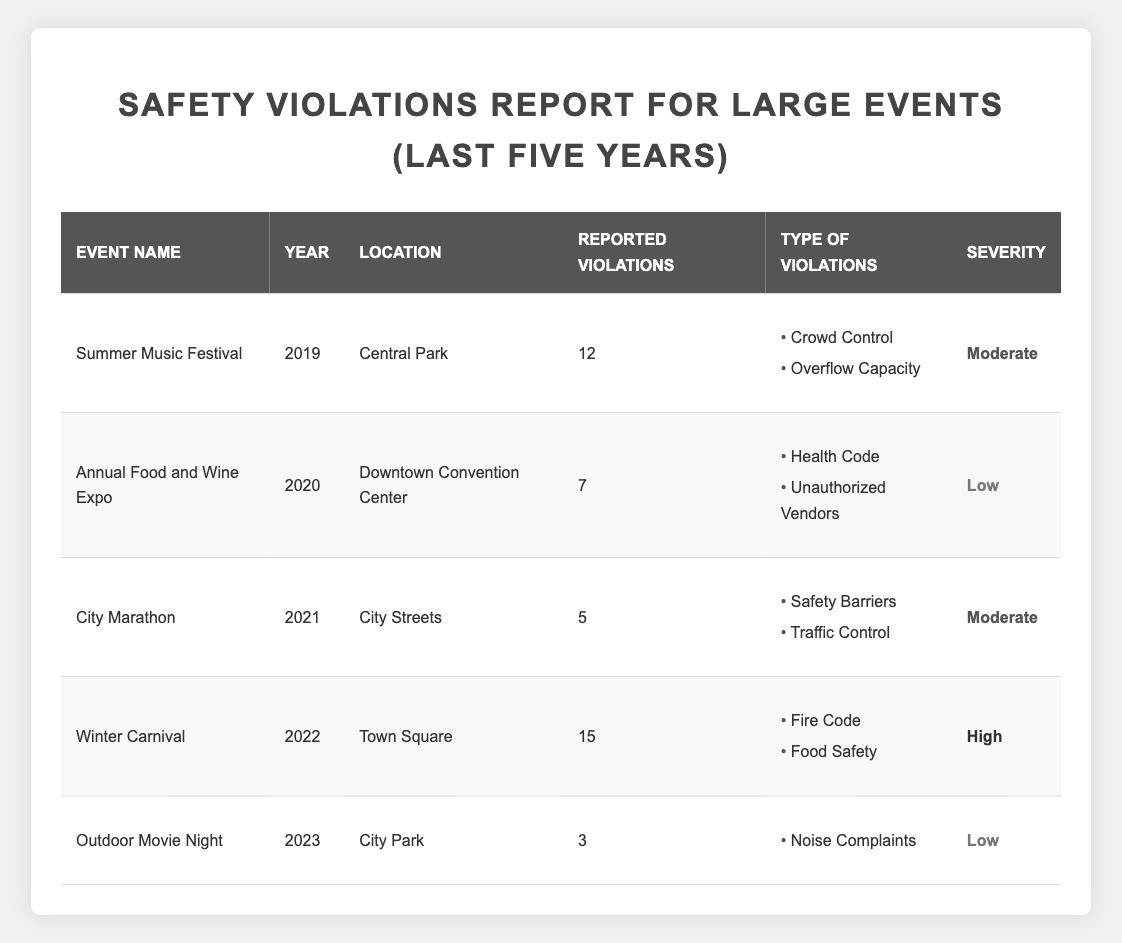What event reported the highest number of violations? Looking at the "Reported Violations" column, "Winter Carnival" has the highest value of 15 violations.
Answer: Winter Carnival How many events reported moderate severity violations? By reviewing the "Severity" column, the events "Summer Music Festival," "City Marathon," and "Winter Carnival" are classified as moderate, totaling 3 events.
Answer: 3 What is the total number of reported violations across all events listed? Adding the reported violations: 12 (Summer Music Festival) + 7 (Annual Food and Wine Expo) + 5 (City Marathon) + 15 (Winter Carnival) + 3 (Outdoor Movie Night) gives a total of 42 reported violations.
Answer: 42 Did the "Annual Food and Wine Expo" report any high severity violations? The "Severity" listed for "Annual Food and Wine Expo" is labeled as low, indicating no high severity violations were reported.
Answer: No In which year did the event with the lowest reported violations occur? The event with the lowest reported violations is "Outdoor Movie Night," which occurred in 2023, as it reported only 3 violations.
Answer: 2023 What is the average number of violations reported per event? To find the average, sum all reported violations (42) and divide by the number of events (5), resulting in an average of 42/5 = 8.4 violations per event.
Answer: 8.4 How many types of violations were reported for the "Winter Carnival"? The "Winter Carnival" reported two types of violations: "Fire Code" and "Food Safety."
Answer: 2 Was there any event in 2021 that had reported violations categorized under health code? The event "City Marathon" in 2021 reported violations related to "Safety Barriers" and "Traffic Control," with no mention of health code violations.
Answer: No Which event had reported violations related to unauthorized vendors? The "Annual Food and Wine Expo" reported violations classified as unauthorized vendors among others in 2020.
Answer: Annual Food and Wine Expo List the events that reported low severity violations. The events with low severity violations are "Annual Food and Wine Expo" and "Outdoor Movie Night," totaling 2 events.
Answer: 2 